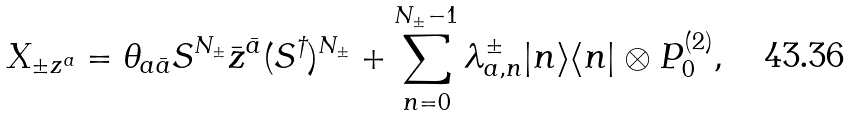<formula> <loc_0><loc_0><loc_500><loc_500>X _ { \pm z ^ { a } } = \theta _ { a \bar { a } } S ^ { N _ { \pm } } \bar { z } ^ { \bar { a } } ( S ^ { \dagger } ) ^ { N _ { \pm } } + \sum _ { n = 0 } ^ { N _ { \pm } - 1 } \lambda _ { a , n } ^ { \pm } | n \rangle \langle n | \otimes P _ { 0 } ^ { ( 2 ) } ,</formula> 